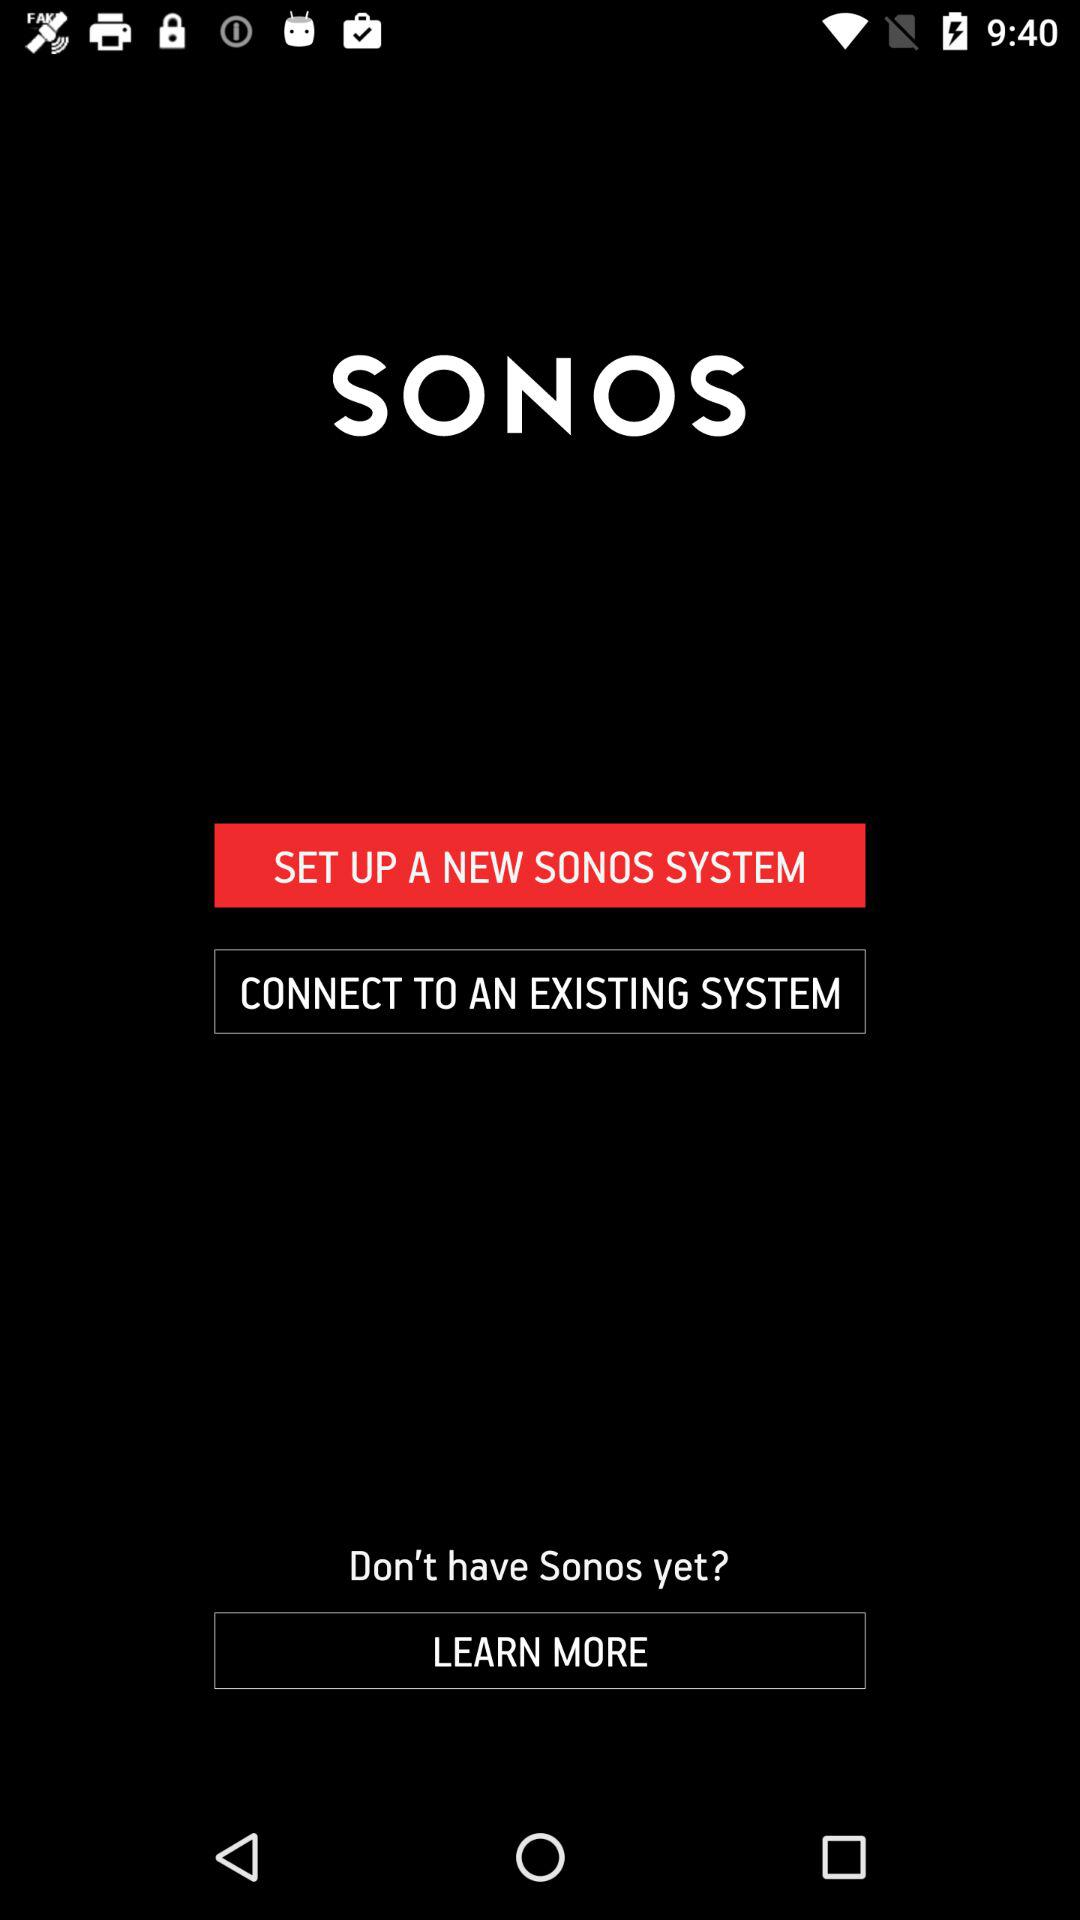What is the application name? The application name is "SONOS". 